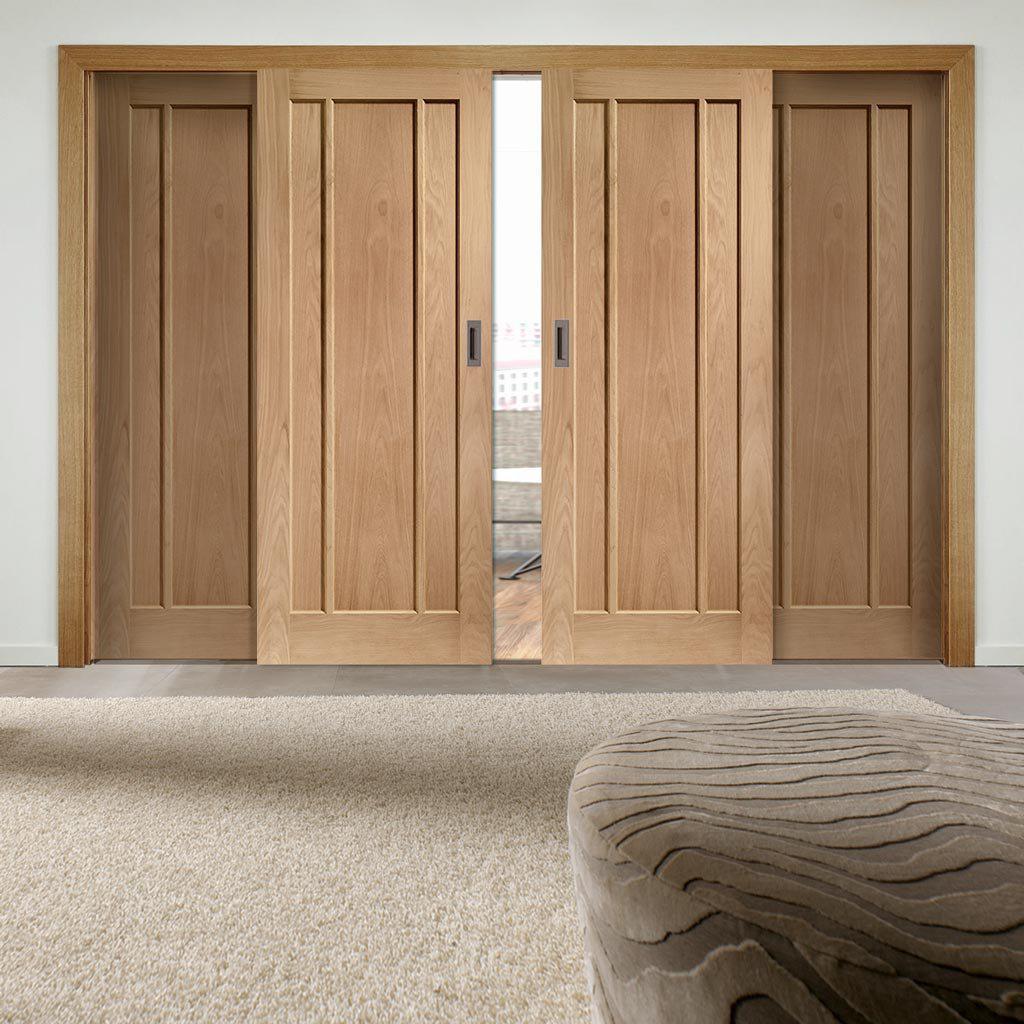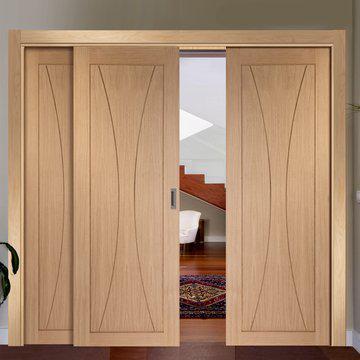The first image is the image on the left, the second image is the image on the right. Given the left and right images, does the statement "At least one set of doors opens with a gap in the center." hold true? Answer yes or no. Yes. 